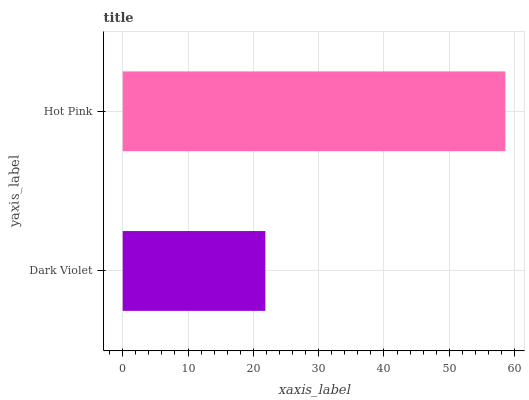Is Dark Violet the minimum?
Answer yes or no. Yes. Is Hot Pink the maximum?
Answer yes or no. Yes. Is Hot Pink the minimum?
Answer yes or no. No. Is Hot Pink greater than Dark Violet?
Answer yes or no. Yes. Is Dark Violet less than Hot Pink?
Answer yes or no. Yes. Is Dark Violet greater than Hot Pink?
Answer yes or no. No. Is Hot Pink less than Dark Violet?
Answer yes or no. No. Is Hot Pink the high median?
Answer yes or no. Yes. Is Dark Violet the low median?
Answer yes or no. Yes. Is Dark Violet the high median?
Answer yes or no. No. Is Hot Pink the low median?
Answer yes or no. No. 